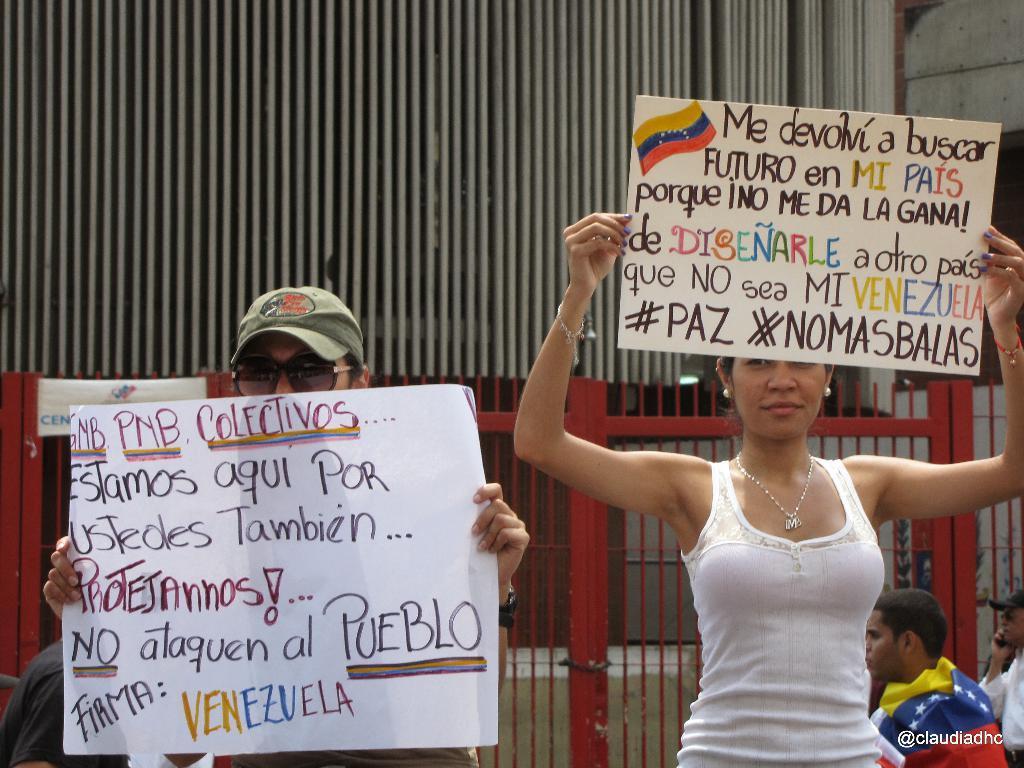Can you describe this image briefly? In this picture we can see two people holding posters and in the background we can see people, get, grills, in the bottom right we can see some text on it. 